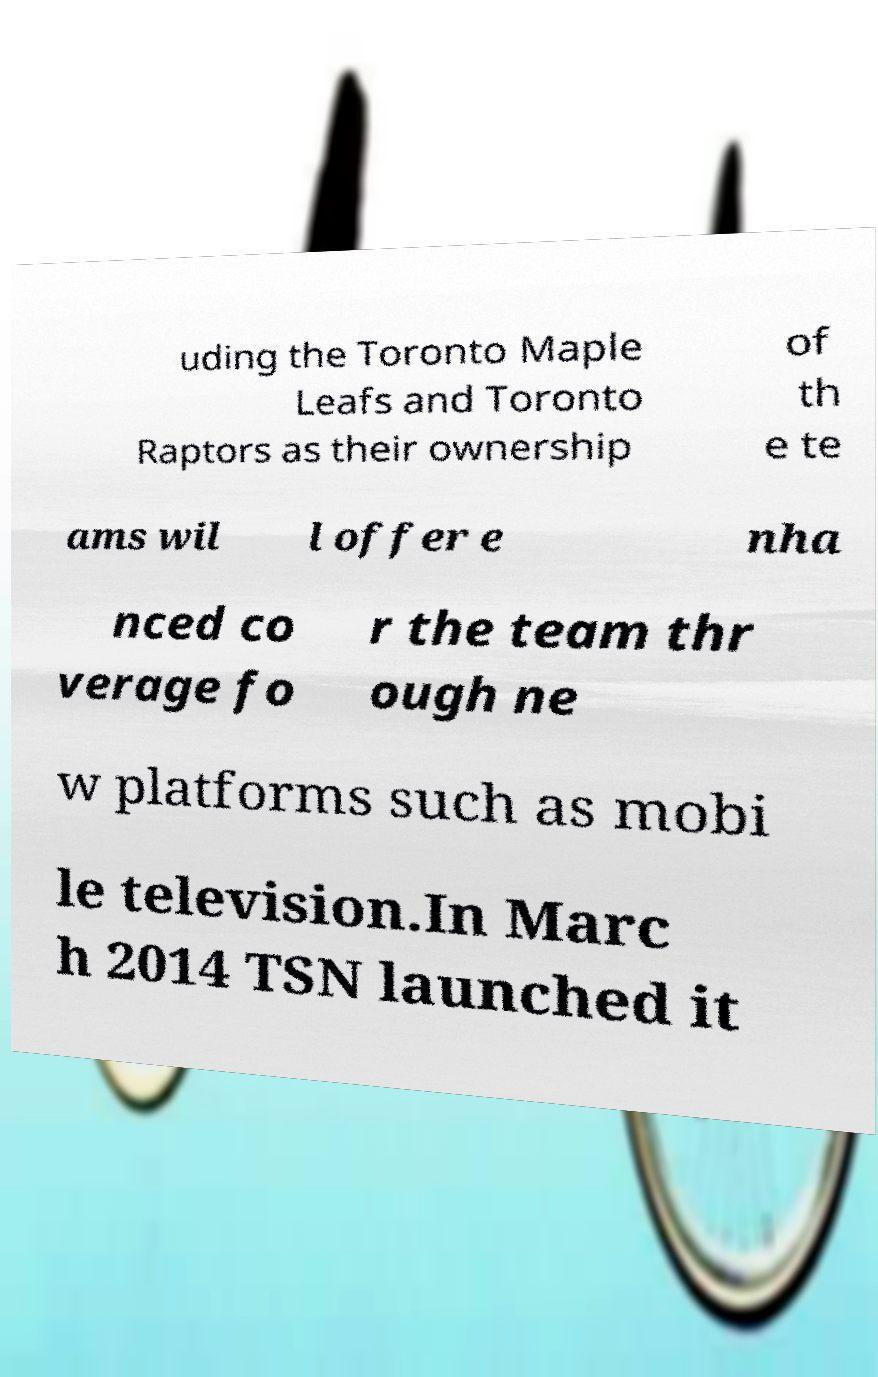Please identify and transcribe the text found in this image. uding the Toronto Maple Leafs and Toronto Raptors as their ownership of th e te ams wil l offer e nha nced co verage fo r the team thr ough ne w platforms such as mobi le television.In Marc h 2014 TSN launched it 